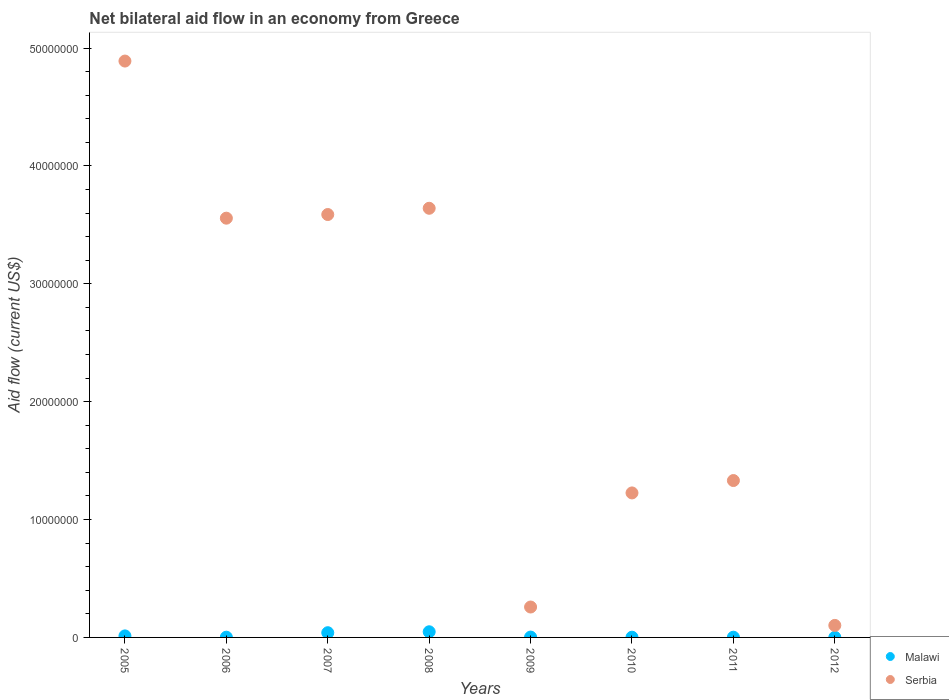Across all years, what is the maximum net bilateral aid flow in Serbia?
Provide a succinct answer. 4.89e+07. Across all years, what is the minimum net bilateral aid flow in Serbia?
Make the answer very short. 1.02e+06. What is the total net bilateral aid flow in Serbia in the graph?
Your answer should be compact. 1.86e+08. What is the difference between the net bilateral aid flow in Serbia in 2006 and that in 2009?
Offer a terse response. 3.30e+07. What is the difference between the net bilateral aid flow in Serbia in 2006 and the net bilateral aid flow in Malawi in 2012?
Your answer should be very brief. 3.56e+07. What is the average net bilateral aid flow in Malawi per year?
Provide a short and direct response. 1.39e+05. In the year 2010, what is the difference between the net bilateral aid flow in Malawi and net bilateral aid flow in Serbia?
Provide a succinct answer. -1.22e+07. In how many years, is the net bilateral aid flow in Malawi greater than 14000000 US$?
Your answer should be very brief. 0. What is the ratio of the net bilateral aid flow in Serbia in 2007 to that in 2011?
Your answer should be very brief. 2.7. Is the net bilateral aid flow in Serbia in 2009 less than that in 2012?
Provide a succinct answer. No. Is the difference between the net bilateral aid flow in Malawi in 2008 and 2009 greater than the difference between the net bilateral aid flow in Serbia in 2008 and 2009?
Your response must be concise. No. What is the difference between the highest and the second highest net bilateral aid flow in Serbia?
Your answer should be compact. 1.25e+07. In how many years, is the net bilateral aid flow in Serbia greater than the average net bilateral aid flow in Serbia taken over all years?
Offer a very short reply. 4. Is the sum of the net bilateral aid flow in Malawi in 2006 and 2008 greater than the maximum net bilateral aid flow in Serbia across all years?
Offer a terse response. No. Does the net bilateral aid flow in Serbia monotonically increase over the years?
Give a very brief answer. No. Is the net bilateral aid flow in Serbia strictly greater than the net bilateral aid flow in Malawi over the years?
Make the answer very short. Yes. Is the net bilateral aid flow in Malawi strictly less than the net bilateral aid flow in Serbia over the years?
Your response must be concise. Yes. What is the difference between two consecutive major ticks on the Y-axis?
Make the answer very short. 1.00e+07. Does the graph contain grids?
Your answer should be compact. No. Where does the legend appear in the graph?
Offer a very short reply. Bottom right. How many legend labels are there?
Your answer should be very brief. 2. How are the legend labels stacked?
Your response must be concise. Vertical. What is the title of the graph?
Offer a terse response. Net bilateral aid flow in an economy from Greece. What is the label or title of the X-axis?
Keep it short and to the point. Years. What is the label or title of the Y-axis?
Offer a very short reply. Aid flow (current US$). What is the Aid flow (current US$) in Serbia in 2005?
Offer a very short reply. 4.89e+07. What is the Aid flow (current US$) of Malawi in 2006?
Make the answer very short. 2.00e+04. What is the Aid flow (current US$) of Serbia in 2006?
Make the answer very short. 3.56e+07. What is the Aid flow (current US$) in Malawi in 2007?
Your response must be concise. 4.00e+05. What is the Aid flow (current US$) of Serbia in 2007?
Ensure brevity in your answer.  3.59e+07. What is the Aid flow (current US$) in Malawi in 2008?
Keep it short and to the point. 4.80e+05. What is the Aid flow (current US$) of Serbia in 2008?
Provide a succinct answer. 3.64e+07. What is the Aid flow (current US$) in Malawi in 2009?
Provide a succinct answer. 3.00e+04. What is the Aid flow (current US$) of Serbia in 2009?
Your response must be concise. 2.58e+06. What is the Aid flow (current US$) of Malawi in 2010?
Give a very brief answer. 2.00e+04. What is the Aid flow (current US$) in Serbia in 2010?
Your response must be concise. 1.23e+07. What is the Aid flow (current US$) in Malawi in 2011?
Ensure brevity in your answer.  2.00e+04. What is the Aid flow (current US$) of Serbia in 2011?
Provide a succinct answer. 1.33e+07. What is the Aid flow (current US$) in Serbia in 2012?
Offer a terse response. 1.02e+06. Across all years, what is the maximum Aid flow (current US$) of Malawi?
Give a very brief answer. 4.80e+05. Across all years, what is the maximum Aid flow (current US$) in Serbia?
Offer a terse response. 4.89e+07. Across all years, what is the minimum Aid flow (current US$) of Serbia?
Offer a terse response. 1.02e+06. What is the total Aid flow (current US$) of Malawi in the graph?
Your answer should be compact. 1.11e+06. What is the total Aid flow (current US$) in Serbia in the graph?
Offer a very short reply. 1.86e+08. What is the difference between the Aid flow (current US$) in Malawi in 2005 and that in 2006?
Ensure brevity in your answer.  1.10e+05. What is the difference between the Aid flow (current US$) in Serbia in 2005 and that in 2006?
Your response must be concise. 1.33e+07. What is the difference between the Aid flow (current US$) in Malawi in 2005 and that in 2007?
Provide a short and direct response. -2.70e+05. What is the difference between the Aid flow (current US$) of Serbia in 2005 and that in 2007?
Ensure brevity in your answer.  1.30e+07. What is the difference between the Aid flow (current US$) in Malawi in 2005 and that in 2008?
Provide a short and direct response. -3.50e+05. What is the difference between the Aid flow (current US$) of Serbia in 2005 and that in 2008?
Your answer should be very brief. 1.25e+07. What is the difference between the Aid flow (current US$) of Malawi in 2005 and that in 2009?
Provide a succinct answer. 1.00e+05. What is the difference between the Aid flow (current US$) in Serbia in 2005 and that in 2009?
Your answer should be compact. 4.63e+07. What is the difference between the Aid flow (current US$) in Serbia in 2005 and that in 2010?
Make the answer very short. 3.66e+07. What is the difference between the Aid flow (current US$) of Serbia in 2005 and that in 2011?
Provide a short and direct response. 3.56e+07. What is the difference between the Aid flow (current US$) of Malawi in 2005 and that in 2012?
Keep it short and to the point. 1.20e+05. What is the difference between the Aid flow (current US$) in Serbia in 2005 and that in 2012?
Provide a succinct answer. 4.79e+07. What is the difference between the Aid flow (current US$) in Malawi in 2006 and that in 2007?
Your answer should be compact. -3.80e+05. What is the difference between the Aid flow (current US$) of Serbia in 2006 and that in 2007?
Provide a short and direct response. -3.10e+05. What is the difference between the Aid flow (current US$) in Malawi in 2006 and that in 2008?
Offer a terse response. -4.60e+05. What is the difference between the Aid flow (current US$) of Serbia in 2006 and that in 2008?
Provide a short and direct response. -8.40e+05. What is the difference between the Aid flow (current US$) of Malawi in 2006 and that in 2009?
Provide a succinct answer. -10000. What is the difference between the Aid flow (current US$) in Serbia in 2006 and that in 2009?
Provide a short and direct response. 3.30e+07. What is the difference between the Aid flow (current US$) in Malawi in 2006 and that in 2010?
Keep it short and to the point. 0. What is the difference between the Aid flow (current US$) in Serbia in 2006 and that in 2010?
Ensure brevity in your answer.  2.33e+07. What is the difference between the Aid flow (current US$) of Malawi in 2006 and that in 2011?
Your response must be concise. 0. What is the difference between the Aid flow (current US$) in Serbia in 2006 and that in 2011?
Offer a very short reply. 2.23e+07. What is the difference between the Aid flow (current US$) in Malawi in 2006 and that in 2012?
Your answer should be compact. 10000. What is the difference between the Aid flow (current US$) in Serbia in 2006 and that in 2012?
Keep it short and to the point. 3.46e+07. What is the difference between the Aid flow (current US$) of Malawi in 2007 and that in 2008?
Provide a succinct answer. -8.00e+04. What is the difference between the Aid flow (current US$) in Serbia in 2007 and that in 2008?
Make the answer very short. -5.30e+05. What is the difference between the Aid flow (current US$) in Malawi in 2007 and that in 2009?
Your response must be concise. 3.70e+05. What is the difference between the Aid flow (current US$) in Serbia in 2007 and that in 2009?
Your answer should be compact. 3.33e+07. What is the difference between the Aid flow (current US$) in Malawi in 2007 and that in 2010?
Your answer should be compact. 3.80e+05. What is the difference between the Aid flow (current US$) of Serbia in 2007 and that in 2010?
Keep it short and to the point. 2.36e+07. What is the difference between the Aid flow (current US$) of Malawi in 2007 and that in 2011?
Offer a terse response. 3.80e+05. What is the difference between the Aid flow (current US$) in Serbia in 2007 and that in 2011?
Keep it short and to the point. 2.26e+07. What is the difference between the Aid flow (current US$) of Malawi in 2007 and that in 2012?
Ensure brevity in your answer.  3.90e+05. What is the difference between the Aid flow (current US$) in Serbia in 2007 and that in 2012?
Keep it short and to the point. 3.49e+07. What is the difference between the Aid flow (current US$) in Malawi in 2008 and that in 2009?
Keep it short and to the point. 4.50e+05. What is the difference between the Aid flow (current US$) in Serbia in 2008 and that in 2009?
Your answer should be very brief. 3.38e+07. What is the difference between the Aid flow (current US$) in Serbia in 2008 and that in 2010?
Provide a short and direct response. 2.42e+07. What is the difference between the Aid flow (current US$) of Serbia in 2008 and that in 2011?
Make the answer very short. 2.31e+07. What is the difference between the Aid flow (current US$) of Serbia in 2008 and that in 2012?
Provide a succinct answer. 3.54e+07. What is the difference between the Aid flow (current US$) in Malawi in 2009 and that in 2010?
Provide a succinct answer. 10000. What is the difference between the Aid flow (current US$) in Serbia in 2009 and that in 2010?
Give a very brief answer. -9.68e+06. What is the difference between the Aid flow (current US$) in Malawi in 2009 and that in 2011?
Your response must be concise. 10000. What is the difference between the Aid flow (current US$) of Serbia in 2009 and that in 2011?
Ensure brevity in your answer.  -1.07e+07. What is the difference between the Aid flow (current US$) in Malawi in 2009 and that in 2012?
Provide a succinct answer. 2.00e+04. What is the difference between the Aid flow (current US$) of Serbia in 2009 and that in 2012?
Ensure brevity in your answer.  1.56e+06. What is the difference between the Aid flow (current US$) in Serbia in 2010 and that in 2011?
Make the answer very short. -1.05e+06. What is the difference between the Aid flow (current US$) of Malawi in 2010 and that in 2012?
Give a very brief answer. 10000. What is the difference between the Aid flow (current US$) in Serbia in 2010 and that in 2012?
Provide a succinct answer. 1.12e+07. What is the difference between the Aid flow (current US$) of Serbia in 2011 and that in 2012?
Make the answer very short. 1.23e+07. What is the difference between the Aid flow (current US$) in Malawi in 2005 and the Aid flow (current US$) in Serbia in 2006?
Your answer should be very brief. -3.54e+07. What is the difference between the Aid flow (current US$) of Malawi in 2005 and the Aid flow (current US$) of Serbia in 2007?
Your answer should be compact. -3.58e+07. What is the difference between the Aid flow (current US$) in Malawi in 2005 and the Aid flow (current US$) in Serbia in 2008?
Make the answer very short. -3.63e+07. What is the difference between the Aid flow (current US$) of Malawi in 2005 and the Aid flow (current US$) of Serbia in 2009?
Make the answer very short. -2.45e+06. What is the difference between the Aid flow (current US$) in Malawi in 2005 and the Aid flow (current US$) in Serbia in 2010?
Your answer should be very brief. -1.21e+07. What is the difference between the Aid flow (current US$) in Malawi in 2005 and the Aid flow (current US$) in Serbia in 2011?
Your answer should be very brief. -1.32e+07. What is the difference between the Aid flow (current US$) of Malawi in 2005 and the Aid flow (current US$) of Serbia in 2012?
Make the answer very short. -8.90e+05. What is the difference between the Aid flow (current US$) in Malawi in 2006 and the Aid flow (current US$) in Serbia in 2007?
Provide a succinct answer. -3.59e+07. What is the difference between the Aid flow (current US$) in Malawi in 2006 and the Aid flow (current US$) in Serbia in 2008?
Your response must be concise. -3.64e+07. What is the difference between the Aid flow (current US$) in Malawi in 2006 and the Aid flow (current US$) in Serbia in 2009?
Make the answer very short. -2.56e+06. What is the difference between the Aid flow (current US$) in Malawi in 2006 and the Aid flow (current US$) in Serbia in 2010?
Make the answer very short. -1.22e+07. What is the difference between the Aid flow (current US$) of Malawi in 2006 and the Aid flow (current US$) of Serbia in 2011?
Your answer should be very brief. -1.33e+07. What is the difference between the Aid flow (current US$) of Malawi in 2006 and the Aid flow (current US$) of Serbia in 2012?
Make the answer very short. -1.00e+06. What is the difference between the Aid flow (current US$) of Malawi in 2007 and the Aid flow (current US$) of Serbia in 2008?
Give a very brief answer. -3.60e+07. What is the difference between the Aid flow (current US$) in Malawi in 2007 and the Aid flow (current US$) in Serbia in 2009?
Provide a short and direct response. -2.18e+06. What is the difference between the Aid flow (current US$) of Malawi in 2007 and the Aid flow (current US$) of Serbia in 2010?
Give a very brief answer. -1.19e+07. What is the difference between the Aid flow (current US$) of Malawi in 2007 and the Aid flow (current US$) of Serbia in 2011?
Your answer should be compact. -1.29e+07. What is the difference between the Aid flow (current US$) in Malawi in 2007 and the Aid flow (current US$) in Serbia in 2012?
Provide a succinct answer. -6.20e+05. What is the difference between the Aid flow (current US$) in Malawi in 2008 and the Aid flow (current US$) in Serbia in 2009?
Ensure brevity in your answer.  -2.10e+06. What is the difference between the Aid flow (current US$) of Malawi in 2008 and the Aid flow (current US$) of Serbia in 2010?
Your response must be concise. -1.18e+07. What is the difference between the Aid flow (current US$) in Malawi in 2008 and the Aid flow (current US$) in Serbia in 2011?
Give a very brief answer. -1.28e+07. What is the difference between the Aid flow (current US$) of Malawi in 2008 and the Aid flow (current US$) of Serbia in 2012?
Offer a very short reply. -5.40e+05. What is the difference between the Aid flow (current US$) in Malawi in 2009 and the Aid flow (current US$) in Serbia in 2010?
Offer a terse response. -1.22e+07. What is the difference between the Aid flow (current US$) in Malawi in 2009 and the Aid flow (current US$) in Serbia in 2011?
Your response must be concise. -1.33e+07. What is the difference between the Aid flow (current US$) in Malawi in 2009 and the Aid flow (current US$) in Serbia in 2012?
Offer a terse response. -9.90e+05. What is the difference between the Aid flow (current US$) of Malawi in 2010 and the Aid flow (current US$) of Serbia in 2011?
Make the answer very short. -1.33e+07. What is the difference between the Aid flow (current US$) of Malawi in 2010 and the Aid flow (current US$) of Serbia in 2012?
Give a very brief answer. -1.00e+06. What is the difference between the Aid flow (current US$) of Malawi in 2011 and the Aid flow (current US$) of Serbia in 2012?
Offer a terse response. -1.00e+06. What is the average Aid flow (current US$) of Malawi per year?
Ensure brevity in your answer.  1.39e+05. What is the average Aid flow (current US$) of Serbia per year?
Your response must be concise. 2.32e+07. In the year 2005, what is the difference between the Aid flow (current US$) of Malawi and Aid flow (current US$) of Serbia?
Provide a succinct answer. -4.88e+07. In the year 2006, what is the difference between the Aid flow (current US$) of Malawi and Aid flow (current US$) of Serbia?
Provide a short and direct response. -3.56e+07. In the year 2007, what is the difference between the Aid flow (current US$) of Malawi and Aid flow (current US$) of Serbia?
Offer a terse response. -3.55e+07. In the year 2008, what is the difference between the Aid flow (current US$) in Malawi and Aid flow (current US$) in Serbia?
Ensure brevity in your answer.  -3.59e+07. In the year 2009, what is the difference between the Aid flow (current US$) in Malawi and Aid flow (current US$) in Serbia?
Your answer should be compact. -2.55e+06. In the year 2010, what is the difference between the Aid flow (current US$) in Malawi and Aid flow (current US$) in Serbia?
Your answer should be very brief. -1.22e+07. In the year 2011, what is the difference between the Aid flow (current US$) in Malawi and Aid flow (current US$) in Serbia?
Give a very brief answer. -1.33e+07. In the year 2012, what is the difference between the Aid flow (current US$) of Malawi and Aid flow (current US$) of Serbia?
Offer a terse response. -1.01e+06. What is the ratio of the Aid flow (current US$) in Serbia in 2005 to that in 2006?
Your answer should be very brief. 1.37. What is the ratio of the Aid flow (current US$) in Malawi in 2005 to that in 2007?
Your answer should be compact. 0.33. What is the ratio of the Aid flow (current US$) of Serbia in 2005 to that in 2007?
Your answer should be compact. 1.36. What is the ratio of the Aid flow (current US$) of Malawi in 2005 to that in 2008?
Your answer should be very brief. 0.27. What is the ratio of the Aid flow (current US$) of Serbia in 2005 to that in 2008?
Make the answer very short. 1.34. What is the ratio of the Aid flow (current US$) in Malawi in 2005 to that in 2009?
Keep it short and to the point. 4.33. What is the ratio of the Aid flow (current US$) of Serbia in 2005 to that in 2009?
Ensure brevity in your answer.  18.95. What is the ratio of the Aid flow (current US$) of Malawi in 2005 to that in 2010?
Your answer should be compact. 6.5. What is the ratio of the Aid flow (current US$) of Serbia in 2005 to that in 2010?
Ensure brevity in your answer.  3.99. What is the ratio of the Aid flow (current US$) in Malawi in 2005 to that in 2011?
Provide a short and direct response. 6.5. What is the ratio of the Aid flow (current US$) in Serbia in 2005 to that in 2011?
Provide a short and direct response. 3.67. What is the ratio of the Aid flow (current US$) in Malawi in 2005 to that in 2012?
Keep it short and to the point. 13. What is the ratio of the Aid flow (current US$) of Serbia in 2005 to that in 2012?
Your answer should be very brief. 47.94. What is the ratio of the Aid flow (current US$) of Malawi in 2006 to that in 2007?
Offer a terse response. 0.05. What is the ratio of the Aid flow (current US$) in Malawi in 2006 to that in 2008?
Offer a terse response. 0.04. What is the ratio of the Aid flow (current US$) in Serbia in 2006 to that in 2008?
Keep it short and to the point. 0.98. What is the ratio of the Aid flow (current US$) in Malawi in 2006 to that in 2009?
Your response must be concise. 0.67. What is the ratio of the Aid flow (current US$) of Serbia in 2006 to that in 2009?
Ensure brevity in your answer.  13.79. What is the ratio of the Aid flow (current US$) in Serbia in 2006 to that in 2010?
Keep it short and to the point. 2.9. What is the ratio of the Aid flow (current US$) in Malawi in 2006 to that in 2011?
Your response must be concise. 1. What is the ratio of the Aid flow (current US$) in Serbia in 2006 to that in 2011?
Your answer should be very brief. 2.67. What is the ratio of the Aid flow (current US$) of Malawi in 2006 to that in 2012?
Give a very brief answer. 2. What is the ratio of the Aid flow (current US$) of Serbia in 2006 to that in 2012?
Provide a succinct answer. 34.87. What is the ratio of the Aid flow (current US$) of Malawi in 2007 to that in 2008?
Make the answer very short. 0.83. What is the ratio of the Aid flow (current US$) of Serbia in 2007 to that in 2008?
Keep it short and to the point. 0.99. What is the ratio of the Aid flow (current US$) in Malawi in 2007 to that in 2009?
Provide a succinct answer. 13.33. What is the ratio of the Aid flow (current US$) of Serbia in 2007 to that in 2009?
Your answer should be very brief. 13.91. What is the ratio of the Aid flow (current US$) in Serbia in 2007 to that in 2010?
Provide a succinct answer. 2.93. What is the ratio of the Aid flow (current US$) of Serbia in 2007 to that in 2011?
Offer a terse response. 2.7. What is the ratio of the Aid flow (current US$) in Serbia in 2007 to that in 2012?
Offer a terse response. 35.18. What is the ratio of the Aid flow (current US$) in Malawi in 2008 to that in 2009?
Provide a short and direct response. 16. What is the ratio of the Aid flow (current US$) of Serbia in 2008 to that in 2009?
Your answer should be compact. 14.11. What is the ratio of the Aid flow (current US$) in Serbia in 2008 to that in 2010?
Make the answer very short. 2.97. What is the ratio of the Aid flow (current US$) of Malawi in 2008 to that in 2011?
Offer a terse response. 24. What is the ratio of the Aid flow (current US$) in Serbia in 2008 to that in 2011?
Offer a very short reply. 2.74. What is the ratio of the Aid flow (current US$) of Malawi in 2008 to that in 2012?
Your answer should be compact. 48. What is the ratio of the Aid flow (current US$) in Serbia in 2008 to that in 2012?
Keep it short and to the point. 35.7. What is the ratio of the Aid flow (current US$) of Serbia in 2009 to that in 2010?
Your answer should be very brief. 0.21. What is the ratio of the Aid flow (current US$) of Serbia in 2009 to that in 2011?
Keep it short and to the point. 0.19. What is the ratio of the Aid flow (current US$) in Malawi in 2009 to that in 2012?
Offer a very short reply. 3. What is the ratio of the Aid flow (current US$) in Serbia in 2009 to that in 2012?
Provide a short and direct response. 2.53. What is the ratio of the Aid flow (current US$) in Malawi in 2010 to that in 2011?
Give a very brief answer. 1. What is the ratio of the Aid flow (current US$) of Serbia in 2010 to that in 2011?
Provide a succinct answer. 0.92. What is the ratio of the Aid flow (current US$) of Malawi in 2010 to that in 2012?
Provide a short and direct response. 2. What is the ratio of the Aid flow (current US$) of Serbia in 2010 to that in 2012?
Keep it short and to the point. 12.02. What is the ratio of the Aid flow (current US$) in Serbia in 2011 to that in 2012?
Ensure brevity in your answer.  13.05. What is the difference between the highest and the second highest Aid flow (current US$) in Serbia?
Keep it short and to the point. 1.25e+07. What is the difference between the highest and the lowest Aid flow (current US$) of Serbia?
Offer a terse response. 4.79e+07. 